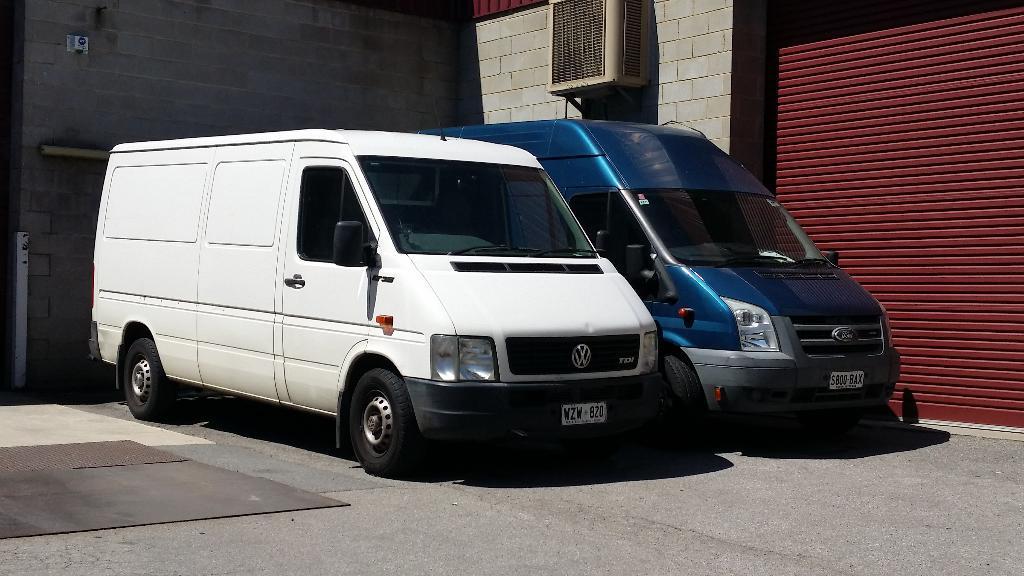Can you describe this image briefly? In this image we can see vehicles. In the back there is a brick wall. On the right side we can see a shutter. On the wall there is an electronic device. 